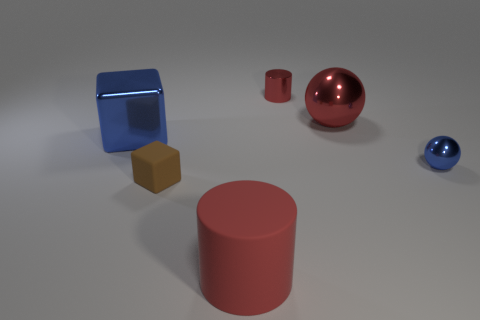Add 3 large red rubber cylinders. How many objects exist? 9 Subtract all balls. How many objects are left? 4 Subtract all big green blocks. Subtract all tiny metal cylinders. How many objects are left? 5 Add 3 blue metallic objects. How many blue metallic objects are left? 5 Add 6 tiny spheres. How many tiny spheres exist? 7 Subtract 0 green cubes. How many objects are left? 6 